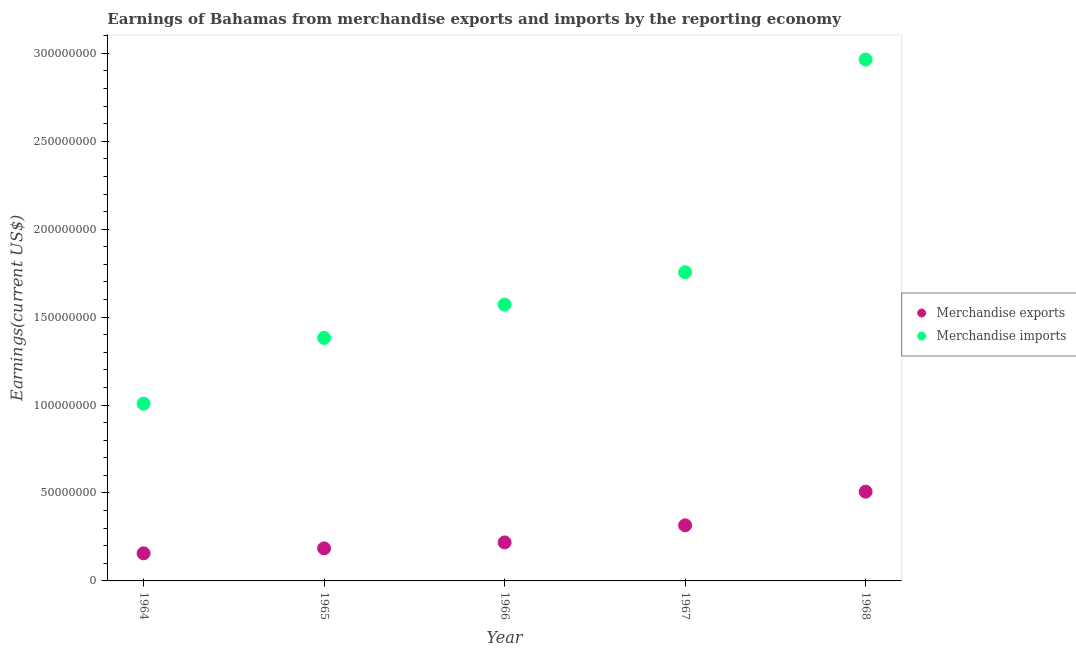How many different coloured dotlines are there?
Offer a very short reply. 2. What is the earnings from merchandise imports in 1965?
Your answer should be very brief. 1.38e+08. Across all years, what is the maximum earnings from merchandise imports?
Offer a very short reply. 2.96e+08. Across all years, what is the minimum earnings from merchandise imports?
Ensure brevity in your answer.  1.01e+08. In which year was the earnings from merchandise exports maximum?
Offer a very short reply. 1968. In which year was the earnings from merchandise exports minimum?
Provide a succinct answer. 1964. What is the total earnings from merchandise exports in the graph?
Offer a very short reply. 1.38e+08. What is the difference between the earnings from merchandise exports in 1964 and that in 1967?
Your answer should be very brief. -1.59e+07. What is the difference between the earnings from merchandise exports in 1968 and the earnings from merchandise imports in 1965?
Make the answer very short. -8.75e+07. What is the average earnings from merchandise imports per year?
Offer a very short reply. 1.74e+08. In the year 1968, what is the difference between the earnings from merchandise imports and earnings from merchandise exports?
Offer a very short reply. 2.46e+08. In how many years, is the earnings from merchandise imports greater than 90000000 US$?
Give a very brief answer. 5. What is the ratio of the earnings from merchandise exports in 1966 to that in 1968?
Keep it short and to the point. 0.43. What is the difference between the highest and the second highest earnings from merchandise imports?
Provide a succinct answer. 1.21e+08. What is the difference between the highest and the lowest earnings from merchandise imports?
Keep it short and to the point. 1.96e+08. In how many years, is the earnings from merchandise exports greater than the average earnings from merchandise exports taken over all years?
Provide a succinct answer. 2. Does the earnings from merchandise exports monotonically increase over the years?
Ensure brevity in your answer.  Yes. Is the earnings from merchandise exports strictly greater than the earnings from merchandise imports over the years?
Make the answer very short. No. How many dotlines are there?
Keep it short and to the point. 2. Does the graph contain grids?
Provide a succinct answer. No. How many legend labels are there?
Your answer should be compact. 2. What is the title of the graph?
Make the answer very short. Earnings of Bahamas from merchandise exports and imports by the reporting economy. Does "% of gross capital formation" appear as one of the legend labels in the graph?
Your response must be concise. No. What is the label or title of the Y-axis?
Your response must be concise. Earnings(current US$). What is the Earnings(current US$) of Merchandise exports in 1964?
Offer a terse response. 1.57e+07. What is the Earnings(current US$) in Merchandise imports in 1964?
Provide a succinct answer. 1.01e+08. What is the Earnings(current US$) in Merchandise exports in 1965?
Keep it short and to the point. 1.85e+07. What is the Earnings(current US$) in Merchandise imports in 1965?
Keep it short and to the point. 1.38e+08. What is the Earnings(current US$) of Merchandise exports in 1966?
Keep it short and to the point. 2.19e+07. What is the Earnings(current US$) of Merchandise imports in 1966?
Offer a terse response. 1.57e+08. What is the Earnings(current US$) in Merchandise exports in 1967?
Offer a very short reply. 3.16e+07. What is the Earnings(current US$) in Merchandise imports in 1967?
Your answer should be very brief. 1.76e+08. What is the Earnings(current US$) of Merchandise exports in 1968?
Ensure brevity in your answer.  5.07e+07. What is the Earnings(current US$) of Merchandise imports in 1968?
Provide a succinct answer. 2.96e+08. Across all years, what is the maximum Earnings(current US$) in Merchandise exports?
Keep it short and to the point. 5.07e+07. Across all years, what is the maximum Earnings(current US$) of Merchandise imports?
Make the answer very short. 2.96e+08. Across all years, what is the minimum Earnings(current US$) of Merchandise exports?
Provide a succinct answer. 1.57e+07. Across all years, what is the minimum Earnings(current US$) of Merchandise imports?
Give a very brief answer. 1.01e+08. What is the total Earnings(current US$) in Merchandise exports in the graph?
Your response must be concise. 1.38e+08. What is the total Earnings(current US$) in Merchandise imports in the graph?
Provide a short and direct response. 8.68e+08. What is the difference between the Earnings(current US$) in Merchandise exports in 1964 and that in 1965?
Give a very brief answer. -2.80e+06. What is the difference between the Earnings(current US$) of Merchandise imports in 1964 and that in 1965?
Keep it short and to the point. -3.74e+07. What is the difference between the Earnings(current US$) in Merchandise exports in 1964 and that in 1966?
Your answer should be very brief. -6.20e+06. What is the difference between the Earnings(current US$) of Merchandise imports in 1964 and that in 1966?
Keep it short and to the point. -5.63e+07. What is the difference between the Earnings(current US$) in Merchandise exports in 1964 and that in 1967?
Keep it short and to the point. -1.59e+07. What is the difference between the Earnings(current US$) in Merchandise imports in 1964 and that in 1967?
Provide a succinct answer. -7.47e+07. What is the difference between the Earnings(current US$) in Merchandise exports in 1964 and that in 1968?
Offer a very short reply. -3.50e+07. What is the difference between the Earnings(current US$) in Merchandise imports in 1964 and that in 1968?
Ensure brevity in your answer.  -1.96e+08. What is the difference between the Earnings(current US$) in Merchandise exports in 1965 and that in 1966?
Keep it short and to the point. -3.40e+06. What is the difference between the Earnings(current US$) in Merchandise imports in 1965 and that in 1966?
Keep it short and to the point. -1.89e+07. What is the difference between the Earnings(current US$) in Merchandise exports in 1965 and that in 1967?
Make the answer very short. -1.31e+07. What is the difference between the Earnings(current US$) of Merchandise imports in 1965 and that in 1967?
Keep it short and to the point. -3.73e+07. What is the difference between the Earnings(current US$) in Merchandise exports in 1965 and that in 1968?
Keep it short and to the point. -3.22e+07. What is the difference between the Earnings(current US$) of Merchandise imports in 1965 and that in 1968?
Your answer should be compact. -1.58e+08. What is the difference between the Earnings(current US$) of Merchandise exports in 1966 and that in 1967?
Make the answer very short. -9.72e+06. What is the difference between the Earnings(current US$) of Merchandise imports in 1966 and that in 1967?
Your answer should be compact. -1.84e+07. What is the difference between the Earnings(current US$) of Merchandise exports in 1966 and that in 1968?
Your answer should be very brief. -2.88e+07. What is the difference between the Earnings(current US$) of Merchandise imports in 1966 and that in 1968?
Make the answer very short. -1.39e+08. What is the difference between the Earnings(current US$) in Merchandise exports in 1967 and that in 1968?
Offer a very short reply. -1.91e+07. What is the difference between the Earnings(current US$) of Merchandise imports in 1967 and that in 1968?
Provide a short and direct response. -1.21e+08. What is the difference between the Earnings(current US$) in Merchandise exports in 1964 and the Earnings(current US$) in Merchandise imports in 1965?
Make the answer very short. -1.22e+08. What is the difference between the Earnings(current US$) in Merchandise exports in 1964 and the Earnings(current US$) in Merchandise imports in 1966?
Your response must be concise. -1.41e+08. What is the difference between the Earnings(current US$) in Merchandise exports in 1964 and the Earnings(current US$) in Merchandise imports in 1967?
Offer a very short reply. -1.60e+08. What is the difference between the Earnings(current US$) of Merchandise exports in 1964 and the Earnings(current US$) of Merchandise imports in 1968?
Your answer should be compact. -2.81e+08. What is the difference between the Earnings(current US$) in Merchandise exports in 1965 and the Earnings(current US$) in Merchandise imports in 1966?
Your answer should be compact. -1.39e+08. What is the difference between the Earnings(current US$) in Merchandise exports in 1965 and the Earnings(current US$) in Merchandise imports in 1967?
Make the answer very short. -1.57e+08. What is the difference between the Earnings(current US$) in Merchandise exports in 1965 and the Earnings(current US$) in Merchandise imports in 1968?
Make the answer very short. -2.78e+08. What is the difference between the Earnings(current US$) of Merchandise exports in 1966 and the Earnings(current US$) of Merchandise imports in 1967?
Keep it short and to the point. -1.54e+08. What is the difference between the Earnings(current US$) of Merchandise exports in 1966 and the Earnings(current US$) of Merchandise imports in 1968?
Keep it short and to the point. -2.75e+08. What is the difference between the Earnings(current US$) in Merchandise exports in 1967 and the Earnings(current US$) in Merchandise imports in 1968?
Your response must be concise. -2.65e+08. What is the average Earnings(current US$) in Merchandise exports per year?
Make the answer very short. 2.77e+07. What is the average Earnings(current US$) of Merchandise imports per year?
Offer a very short reply. 1.74e+08. In the year 1964, what is the difference between the Earnings(current US$) of Merchandise exports and Earnings(current US$) of Merchandise imports?
Your response must be concise. -8.51e+07. In the year 1965, what is the difference between the Earnings(current US$) of Merchandise exports and Earnings(current US$) of Merchandise imports?
Ensure brevity in your answer.  -1.20e+08. In the year 1966, what is the difference between the Earnings(current US$) in Merchandise exports and Earnings(current US$) in Merchandise imports?
Your answer should be very brief. -1.35e+08. In the year 1967, what is the difference between the Earnings(current US$) of Merchandise exports and Earnings(current US$) of Merchandise imports?
Ensure brevity in your answer.  -1.44e+08. In the year 1968, what is the difference between the Earnings(current US$) of Merchandise exports and Earnings(current US$) of Merchandise imports?
Keep it short and to the point. -2.46e+08. What is the ratio of the Earnings(current US$) in Merchandise exports in 1964 to that in 1965?
Provide a short and direct response. 0.85. What is the ratio of the Earnings(current US$) in Merchandise imports in 1964 to that in 1965?
Offer a terse response. 0.73. What is the ratio of the Earnings(current US$) of Merchandise exports in 1964 to that in 1966?
Provide a short and direct response. 0.72. What is the ratio of the Earnings(current US$) in Merchandise imports in 1964 to that in 1966?
Ensure brevity in your answer.  0.64. What is the ratio of the Earnings(current US$) of Merchandise exports in 1964 to that in 1967?
Keep it short and to the point. 0.5. What is the ratio of the Earnings(current US$) of Merchandise imports in 1964 to that in 1967?
Provide a succinct answer. 0.57. What is the ratio of the Earnings(current US$) of Merchandise exports in 1964 to that in 1968?
Provide a succinct answer. 0.31. What is the ratio of the Earnings(current US$) in Merchandise imports in 1964 to that in 1968?
Offer a very short reply. 0.34. What is the ratio of the Earnings(current US$) of Merchandise exports in 1965 to that in 1966?
Your answer should be compact. 0.84. What is the ratio of the Earnings(current US$) of Merchandise imports in 1965 to that in 1966?
Your answer should be very brief. 0.88. What is the ratio of the Earnings(current US$) of Merchandise exports in 1965 to that in 1967?
Offer a very short reply. 0.59. What is the ratio of the Earnings(current US$) of Merchandise imports in 1965 to that in 1967?
Give a very brief answer. 0.79. What is the ratio of the Earnings(current US$) in Merchandise exports in 1965 to that in 1968?
Keep it short and to the point. 0.36. What is the ratio of the Earnings(current US$) of Merchandise imports in 1965 to that in 1968?
Offer a terse response. 0.47. What is the ratio of the Earnings(current US$) of Merchandise exports in 1966 to that in 1967?
Offer a terse response. 0.69. What is the ratio of the Earnings(current US$) in Merchandise imports in 1966 to that in 1967?
Provide a short and direct response. 0.9. What is the ratio of the Earnings(current US$) in Merchandise exports in 1966 to that in 1968?
Your answer should be compact. 0.43. What is the ratio of the Earnings(current US$) of Merchandise imports in 1966 to that in 1968?
Offer a very short reply. 0.53. What is the ratio of the Earnings(current US$) in Merchandise exports in 1967 to that in 1968?
Offer a terse response. 0.62. What is the ratio of the Earnings(current US$) in Merchandise imports in 1967 to that in 1968?
Provide a succinct answer. 0.59. What is the difference between the highest and the second highest Earnings(current US$) in Merchandise exports?
Your response must be concise. 1.91e+07. What is the difference between the highest and the second highest Earnings(current US$) in Merchandise imports?
Provide a short and direct response. 1.21e+08. What is the difference between the highest and the lowest Earnings(current US$) of Merchandise exports?
Your answer should be very brief. 3.50e+07. What is the difference between the highest and the lowest Earnings(current US$) in Merchandise imports?
Ensure brevity in your answer.  1.96e+08. 